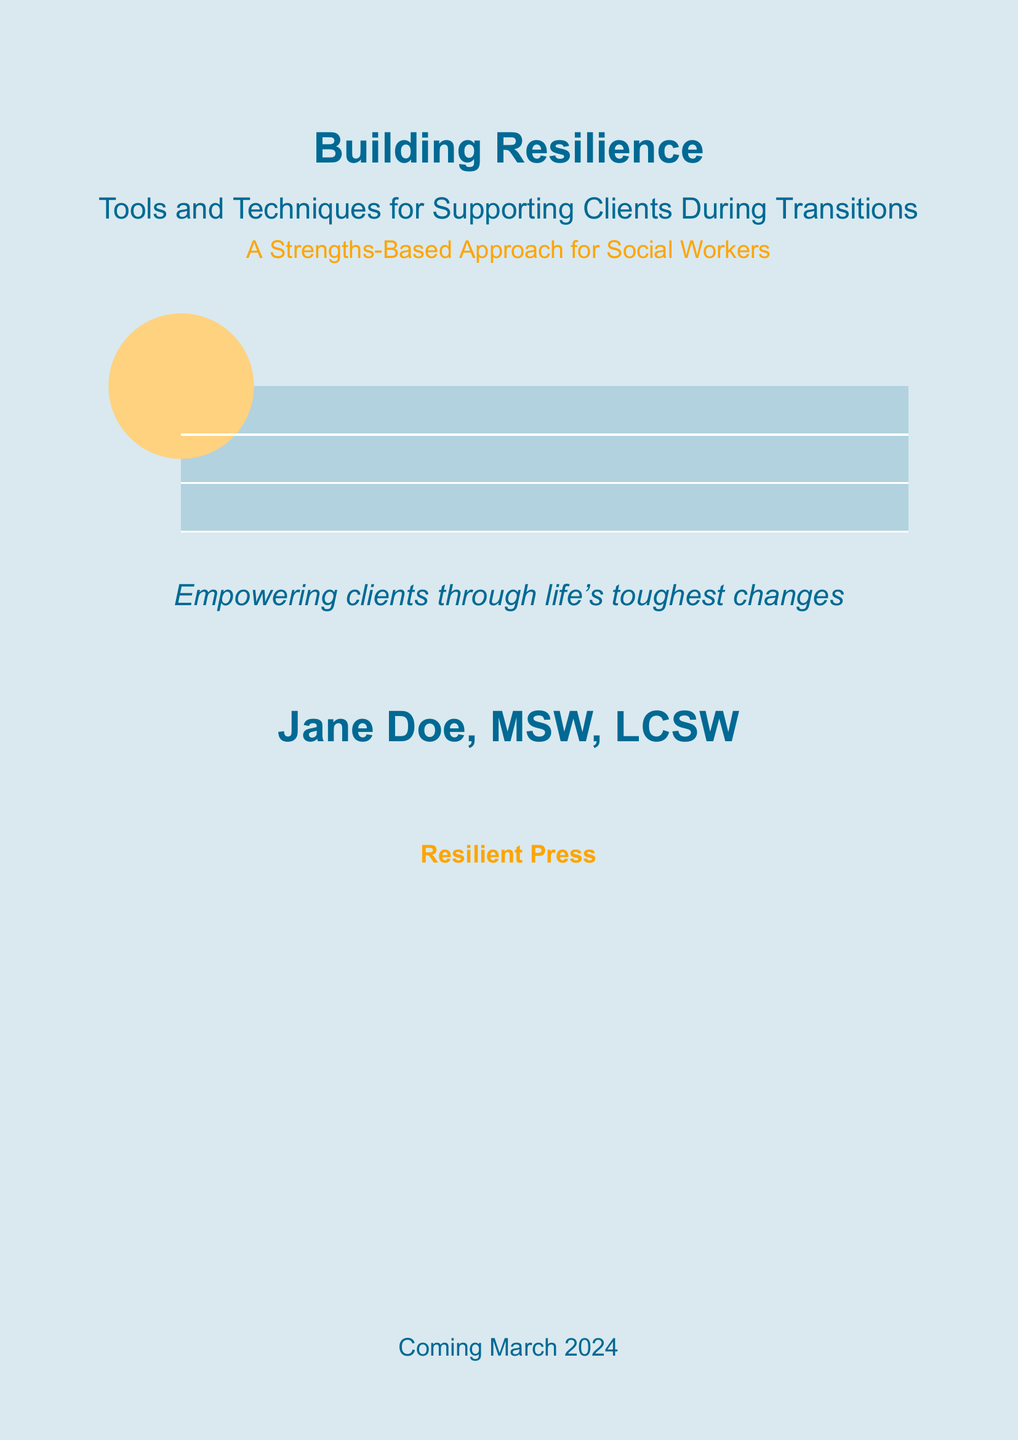what is the title of the book? The title of the book is prominently displayed in large type on the cover.
Answer: Building Resilience who is the author of the book? The author's name is included at the bottom of the cover page.
Answer: Jane Doe, MSW, LCSW what is the publication month of the book? The cover indicates when the book will be available to the public.
Answer: March 2024 what type of approach does the book focus on? The cover highlights the approach emphasized in the book's content.
Answer: Strengths-Based Approach who is the publisher of the book? The publisher's name is found near the bottom of the cover.
Answer: Resilient Press what is the primary purpose of the book? The cover gives insight into the book's main objective.
Answer: Empowering clients through life's toughest changes 